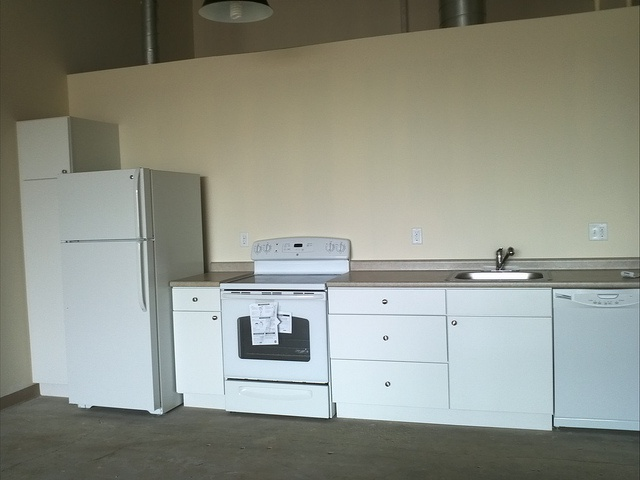Describe the objects in this image and their specific colors. I can see refrigerator in black, darkgray, lightgray, and gray tones, oven in black, lightgray, darkgray, and gray tones, sink in black, gray, darkgray, and white tones, and clock in black, darkgray, and gray tones in this image. 